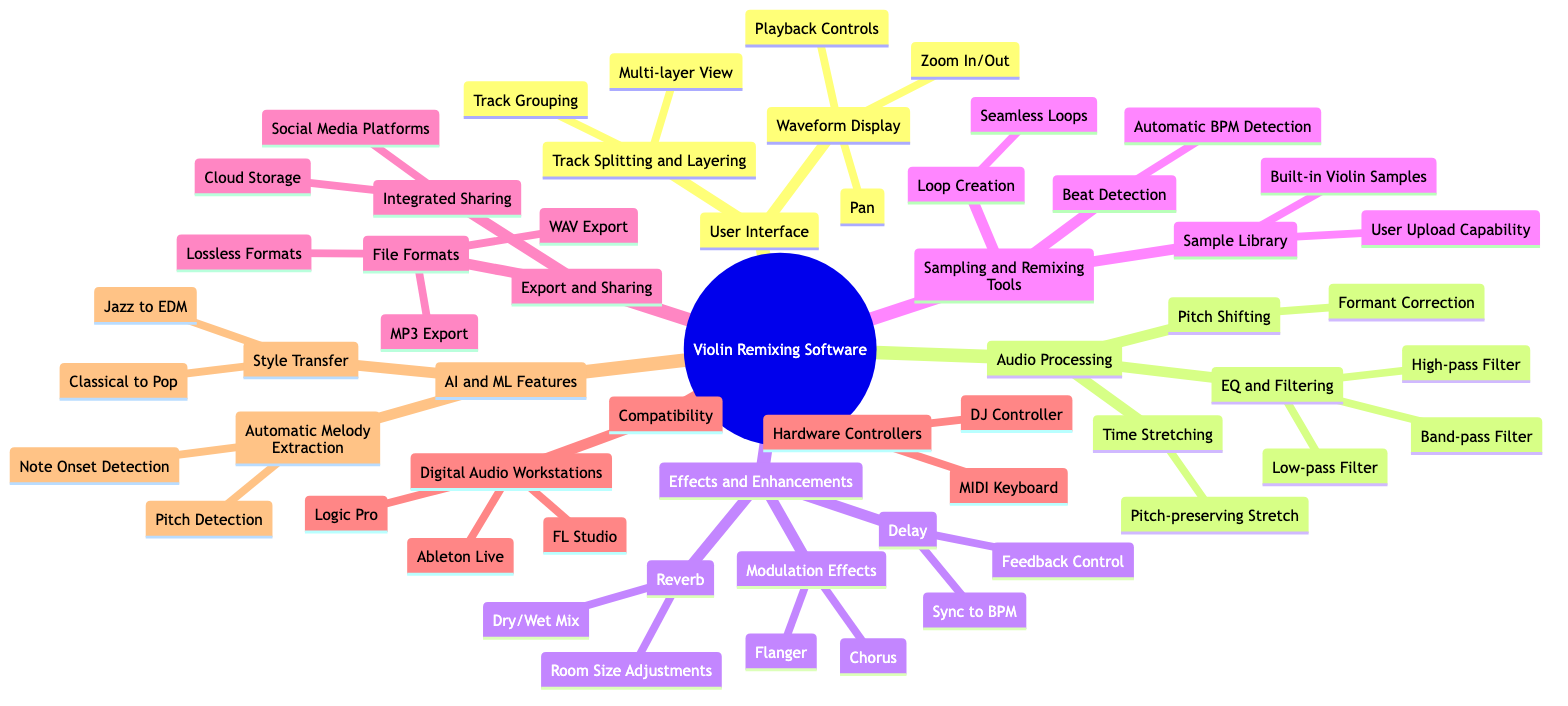What are the components of the User Interface? The User Interface has two main components: Waveform Display and Track Splitting and Layering.
Answer: Waveform Display, Track Splitting and Layering How many effects are listed in the Effects and Enhancements section? There are three effects listed under Effects and Enhancements: Reverb, Delay, and Modulation Effects.
Answer: 3 Which audio processing feature includes a pitch-preserving option? The Time Stretching feature includes the option called Pitch-preserving Stretch.
Answer: Time Stretching What is one of the functionalities under the Sampling and Remixing Tools? Loop Creation is one of the functionalities, specifically noted for creating Seamless Loops.
Answer: Loop Creation In the Compatibility section, what are the examples of Digital Audio Workstations provided? There are three examples given: Ableton Live, FL Studio, and Logic Pro.
Answer: Ableton Live, FL Studio, Logic Pro How is the style transfer feature categorized in the AI and Machine Learning section? Style transfer is categorized under the AI and Machine Learning Features section, with specific examples like Classical to Pop and Jazz to EDM.
Answer: Style Transfer What type of filter is included in the EQ and Filtering feature? The EQ and Filtering feature includes Low-pass Filter, High-pass Filter, and Band-pass Filter.
Answer: Low-pass Filter, High-pass Filter, Band-pass Filter What two components are mentioned in the Export and Sharing section? The Export and Sharing section mentions File Formats and Integrated Sharing as its components.
Answer: File Formats, Integrated Sharing What is the group of controllers listed under Compatibility? The Hardware Controllers group lists MIDI Keyboard and DJ Controller.
Answer: MIDI Keyboard, DJ Controller 